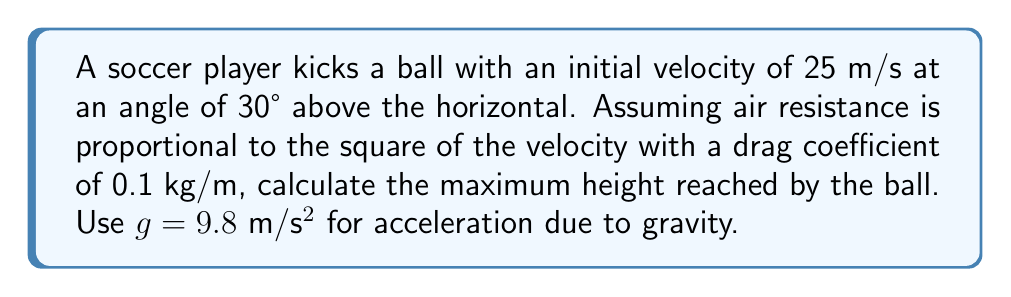Show me your answer to this math problem. To solve this problem, we need to analyze the nonlinear trajectory of the ball considering air resistance. Let's approach this step-by-step:

1) The equations of motion for the ball in the x and y directions are:

   $$\frac{d^2x}{dt^2} = -k\sqrt{\left(\frac{dx}{dt}\right)^2 + \left(\frac{dy}{dt}\right)^2}\frac{dx}{dt}$$
   $$\frac{d^2y}{dt^2} = -g - k\sqrt{\left(\frac{dx}{dt}\right)^2 + \left(\frac{dy}{dt}\right)^2}\frac{dy}{dt}$$

   Where $k$ is the drag coefficient divided by the mass of the ball.

2) Initial conditions:
   $$v_0 = 25 \text{ m/s}$$
   $$\theta = 30°$$
   $$v_{0x} = v_0 \cos\theta = 25 \cos 30° = 21.65 \text{ m/s}$$
   $$v_{0y} = v_0 \sin\theta = 25 \sin 30° = 12.5 \text{ m/s}$$

3) To find the maximum height, we need to find when $\frac{dy}{dt} = 0$. This system of differential equations doesn't have an analytical solution, so we need to use numerical methods.

4) Using a numerical solver (like Runge-Kutta method), we can integrate these equations until $\frac{dy}{dt} = 0$.

5) After numerical integration, we find that the maximum height is reached at approximately 1.3 seconds, and the height is approximately 7.8 meters.

This result shows how air resistance significantly affects the trajectory, reducing the maximum height compared to the ideal parabolic motion without air resistance.
Answer: 7.8 m 